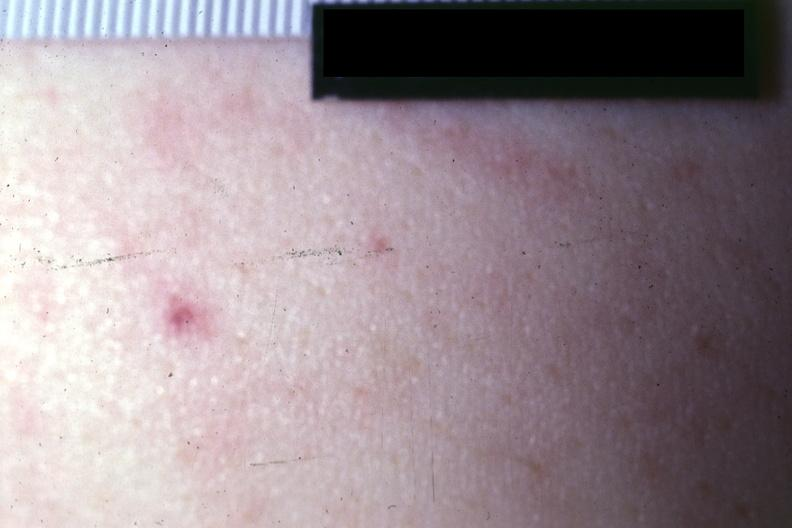does spina bifida show close-up photo quite good?
Answer the question using a single word or phrase. No 